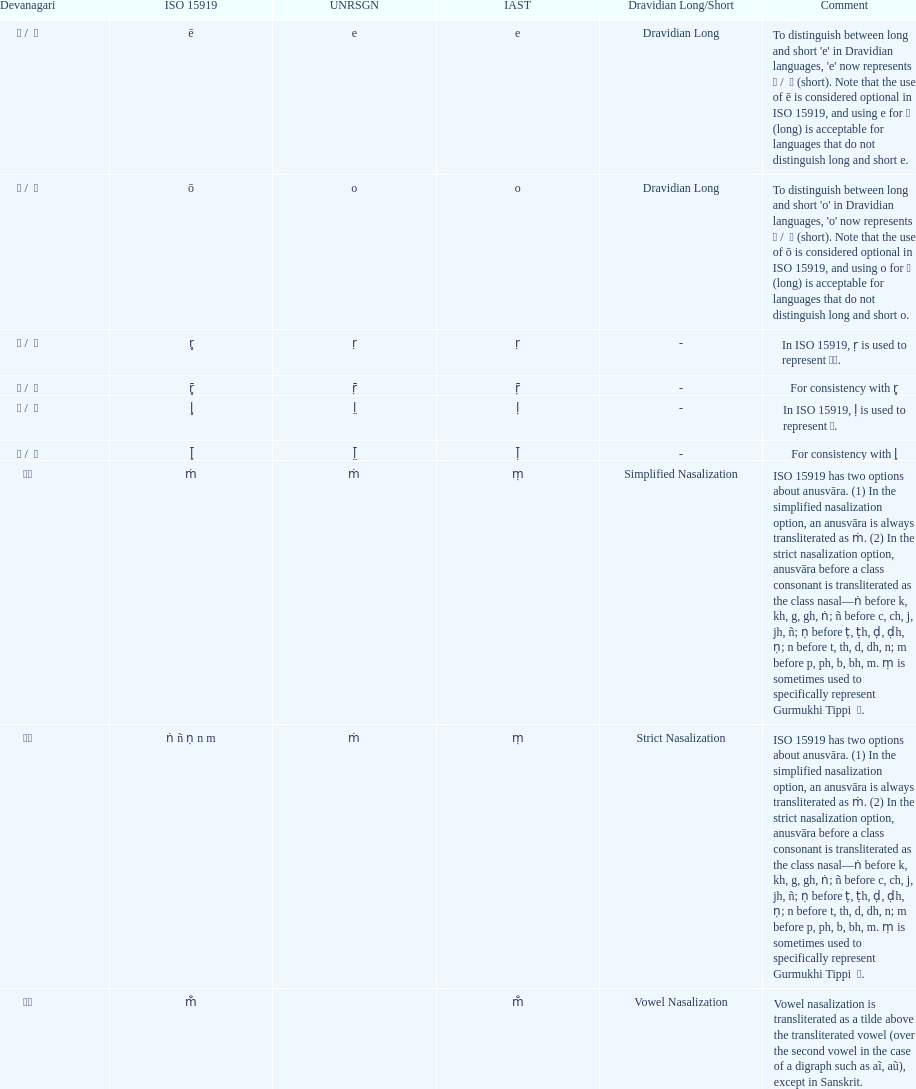In iso 15919, what is mentioned before the use of &#7735; to represent &#2355; under the comments section? For consistency with r̥. 